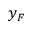Convert formula to latex. <formula><loc_0><loc_0><loc_500><loc_500>y _ { F }</formula> 